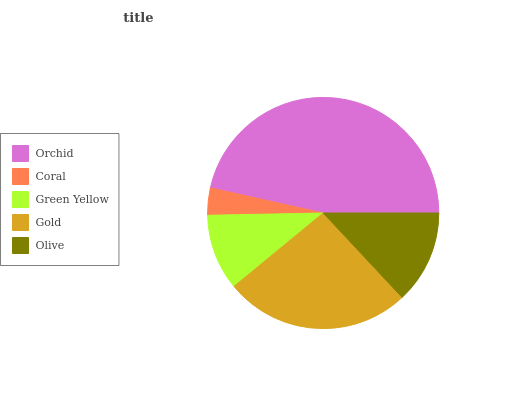Is Coral the minimum?
Answer yes or no. Yes. Is Orchid the maximum?
Answer yes or no. Yes. Is Green Yellow the minimum?
Answer yes or no. No. Is Green Yellow the maximum?
Answer yes or no. No. Is Green Yellow greater than Coral?
Answer yes or no. Yes. Is Coral less than Green Yellow?
Answer yes or no. Yes. Is Coral greater than Green Yellow?
Answer yes or no. No. Is Green Yellow less than Coral?
Answer yes or no. No. Is Olive the high median?
Answer yes or no. Yes. Is Olive the low median?
Answer yes or no. Yes. Is Coral the high median?
Answer yes or no. No. Is Coral the low median?
Answer yes or no. No. 